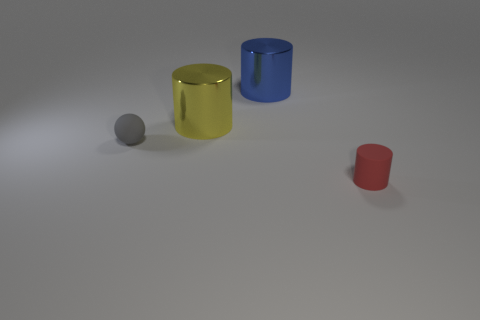What might be the context or setting of this image? The image seems to be set in a controlled environment with a neutral background, likely a studio or a 3D rendering, designed to focus attention on the objects' forms and colors. The lighting suggests an artificial source, further indicating that the setting is designed for display or photograph purposes. 